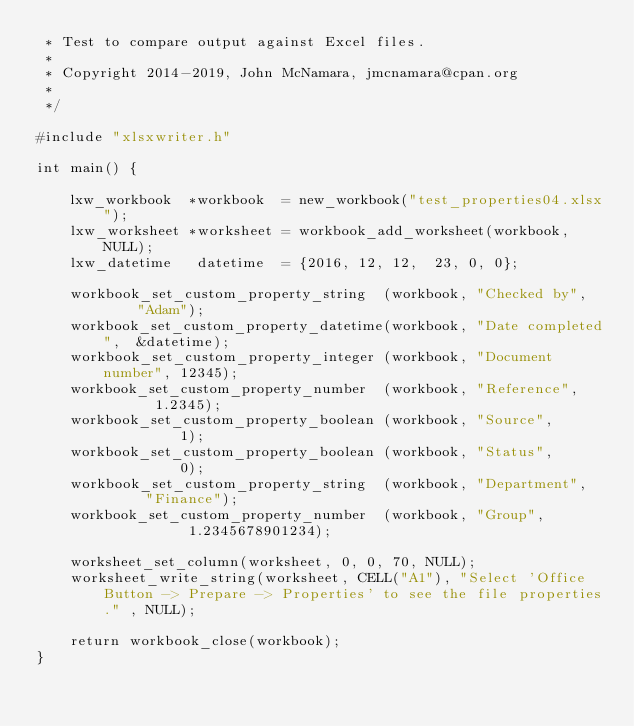<code> <loc_0><loc_0><loc_500><loc_500><_C_> * Test to compare output against Excel files.
 *
 * Copyright 2014-2019, John McNamara, jmcnamara@cpan.org
 *
 */

#include "xlsxwriter.h"

int main() {

    lxw_workbook  *workbook  = new_workbook("test_properties04.xlsx");
    lxw_worksheet *worksheet = workbook_add_worksheet(workbook, NULL);
    lxw_datetime   datetime  = {2016, 12, 12,  23, 0, 0};

    workbook_set_custom_property_string  (workbook, "Checked by",     "Adam");
    workbook_set_custom_property_datetime(workbook, "Date completed",  &datetime);
    workbook_set_custom_property_integer (workbook, "Document number", 12345);
    workbook_set_custom_property_number  (workbook, "Reference",       1.2345);
    workbook_set_custom_property_boolean (workbook, "Source",          1);
    workbook_set_custom_property_boolean (workbook, "Status",          0);
    workbook_set_custom_property_string  (workbook, "Department",      "Finance");
    workbook_set_custom_property_number  (workbook, "Group",           1.2345678901234);

    worksheet_set_column(worksheet, 0, 0, 70, NULL);
    worksheet_write_string(worksheet, CELL("A1"), "Select 'Office Button -> Prepare -> Properties' to see the file properties." , NULL);

    return workbook_close(workbook);
}
</code> 